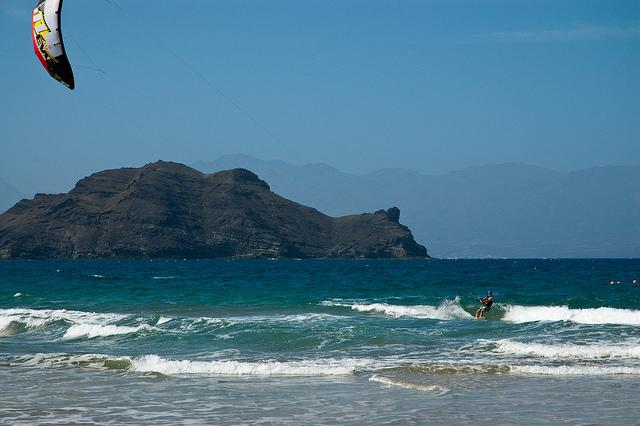What is he doing? wind surfing 